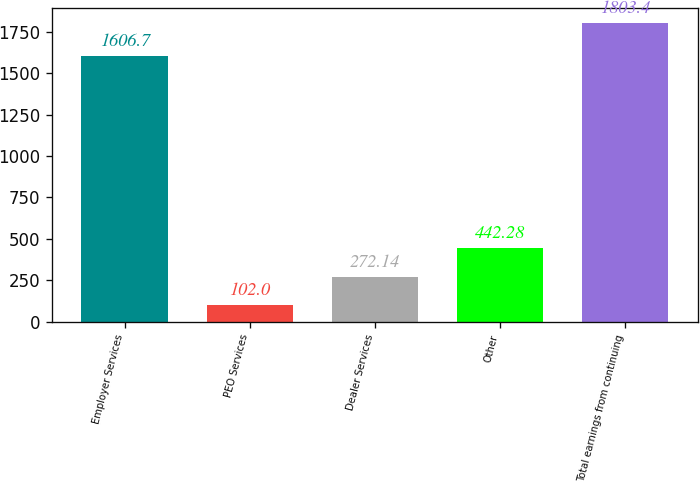<chart> <loc_0><loc_0><loc_500><loc_500><bar_chart><fcel>Employer Services<fcel>PEO Services<fcel>Dealer Services<fcel>Other<fcel>Total earnings from continuing<nl><fcel>1606.7<fcel>102<fcel>272.14<fcel>442.28<fcel>1803.4<nl></chart> 